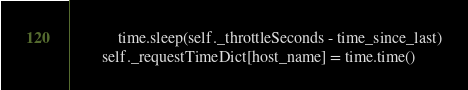<code> <loc_0><loc_0><loc_500><loc_500><_Python_>            time.sleep(self._throttleSeconds - time_since_last)
        self._requestTimeDict[host_name] = time.time()


</code> 